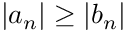<formula> <loc_0><loc_0><loc_500><loc_500>\left | a _ { n } \right | \geq \left | b _ { n } \right |</formula> 